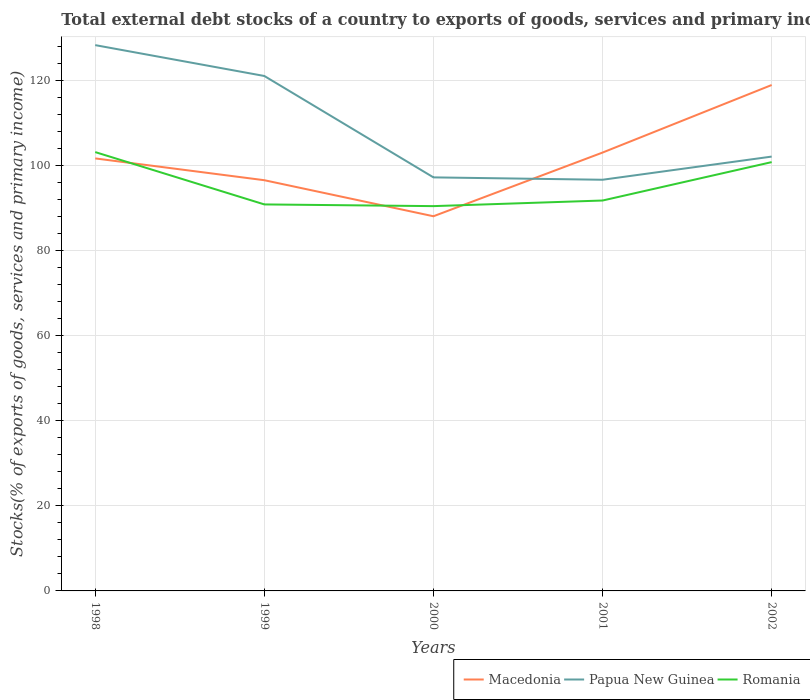How many different coloured lines are there?
Your answer should be very brief. 3. Does the line corresponding to Papua New Guinea intersect with the line corresponding to Macedonia?
Provide a short and direct response. Yes. Is the number of lines equal to the number of legend labels?
Give a very brief answer. Yes. Across all years, what is the maximum total debt stocks in Papua New Guinea?
Ensure brevity in your answer.  96.73. What is the total total debt stocks in Papua New Guinea in the graph?
Keep it short and to the point. 31.11. What is the difference between the highest and the second highest total debt stocks in Romania?
Offer a very short reply. 12.71. What is the difference between the highest and the lowest total debt stocks in Macedonia?
Give a very brief answer. 3. Is the total debt stocks in Papua New Guinea strictly greater than the total debt stocks in Romania over the years?
Make the answer very short. No. How many lines are there?
Offer a terse response. 3. How many years are there in the graph?
Offer a terse response. 5. What is the difference between two consecutive major ticks on the Y-axis?
Offer a very short reply. 20. Are the values on the major ticks of Y-axis written in scientific E-notation?
Offer a terse response. No. How many legend labels are there?
Provide a short and direct response. 3. How are the legend labels stacked?
Give a very brief answer. Horizontal. What is the title of the graph?
Keep it short and to the point. Total external debt stocks of a country to exports of goods, services and primary income. What is the label or title of the Y-axis?
Ensure brevity in your answer.  Stocks(% of exports of goods, services and primary income). What is the Stocks(% of exports of goods, services and primary income) in Macedonia in 1998?
Give a very brief answer. 101.75. What is the Stocks(% of exports of goods, services and primary income) in Papua New Guinea in 1998?
Make the answer very short. 128.4. What is the Stocks(% of exports of goods, services and primary income) of Romania in 1998?
Your response must be concise. 103.24. What is the Stocks(% of exports of goods, services and primary income) in Macedonia in 1999?
Your answer should be very brief. 96.62. What is the Stocks(% of exports of goods, services and primary income) in Papua New Guinea in 1999?
Offer a terse response. 121.14. What is the Stocks(% of exports of goods, services and primary income) of Romania in 1999?
Your answer should be very brief. 90.93. What is the Stocks(% of exports of goods, services and primary income) in Macedonia in 2000?
Keep it short and to the point. 88.14. What is the Stocks(% of exports of goods, services and primary income) in Papua New Guinea in 2000?
Your response must be concise. 97.29. What is the Stocks(% of exports of goods, services and primary income) of Romania in 2000?
Give a very brief answer. 90.52. What is the Stocks(% of exports of goods, services and primary income) of Macedonia in 2001?
Provide a short and direct response. 103.13. What is the Stocks(% of exports of goods, services and primary income) of Papua New Guinea in 2001?
Ensure brevity in your answer.  96.73. What is the Stocks(% of exports of goods, services and primary income) in Romania in 2001?
Give a very brief answer. 91.84. What is the Stocks(% of exports of goods, services and primary income) in Macedonia in 2002?
Provide a short and direct response. 119.02. What is the Stocks(% of exports of goods, services and primary income) in Papua New Guinea in 2002?
Offer a terse response. 102.18. What is the Stocks(% of exports of goods, services and primary income) in Romania in 2002?
Your answer should be very brief. 100.88. Across all years, what is the maximum Stocks(% of exports of goods, services and primary income) of Macedonia?
Give a very brief answer. 119.02. Across all years, what is the maximum Stocks(% of exports of goods, services and primary income) in Papua New Guinea?
Provide a succinct answer. 128.4. Across all years, what is the maximum Stocks(% of exports of goods, services and primary income) of Romania?
Provide a short and direct response. 103.24. Across all years, what is the minimum Stocks(% of exports of goods, services and primary income) of Macedonia?
Provide a succinct answer. 88.14. Across all years, what is the minimum Stocks(% of exports of goods, services and primary income) in Papua New Guinea?
Your response must be concise. 96.73. Across all years, what is the minimum Stocks(% of exports of goods, services and primary income) in Romania?
Provide a short and direct response. 90.52. What is the total Stocks(% of exports of goods, services and primary income) in Macedonia in the graph?
Offer a very short reply. 508.66. What is the total Stocks(% of exports of goods, services and primary income) of Papua New Guinea in the graph?
Give a very brief answer. 545.74. What is the total Stocks(% of exports of goods, services and primary income) in Romania in the graph?
Your answer should be compact. 477.41. What is the difference between the Stocks(% of exports of goods, services and primary income) of Macedonia in 1998 and that in 1999?
Ensure brevity in your answer.  5.13. What is the difference between the Stocks(% of exports of goods, services and primary income) in Papua New Guinea in 1998 and that in 1999?
Give a very brief answer. 7.26. What is the difference between the Stocks(% of exports of goods, services and primary income) in Romania in 1998 and that in 1999?
Give a very brief answer. 12.31. What is the difference between the Stocks(% of exports of goods, services and primary income) of Macedonia in 1998 and that in 2000?
Your answer should be very brief. 13.61. What is the difference between the Stocks(% of exports of goods, services and primary income) of Papua New Guinea in 1998 and that in 2000?
Your response must be concise. 31.11. What is the difference between the Stocks(% of exports of goods, services and primary income) in Romania in 1998 and that in 2000?
Make the answer very short. 12.71. What is the difference between the Stocks(% of exports of goods, services and primary income) of Macedonia in 1998 and that in 2001?
Keep it short and to the point. -1.38. What is the difference between the Stocks(% of exports of goods, services and primary income) in Papua New Guinea in 1998 and that in 2001?
Your response must be concise. 31.67. What is the difference between the Stocks(% of exports of goods, services and primary income) of Romania in 1998 and that in 2001?
Ensure brevity in your answer.  11.39. What is the difference between the Stocks(% of exports of goods, services and primary income) of Macedonia in 1998 and that in 2002?
Offer a terse response. -17.27. What is the difference between the Stocks(% of exports of goods, services and primary income) in Papua New Guinea in 1998 and that in 2002?
Make the answer very short. 26.22. What is the difference between the Stocks(% of exports of goods, services and primary income) of Romania in 1998 and that in 2002?
Give a very brief answer. 2.36. What is the difference between the Stocks(% of exports of goods, services and primary income) of Macedonia in 1999 and that in 2000?
Make the answer very short. 8.48. What is the difference between the Stocks(% of exports of goods, services and primary income) in Papua New Guinea in 1999 and that in 2000?
Offer a terse response. 23.85. What is the difference between the Stocks(% of exports of goods, services and primary income) in Romania in 1999 and that in 2000?
Make the answer very short. 0.4. What is the difference between the Stocks(% of exports of goods, services and primary income) in Macedonia in 1999 and that in 2001?
Keep it short and to the point. -6.5. What is the difference between the Stocks(% of exports of goods, services and primary income) of Papua New Guinea in 1999 and that in 2001?
Provide a short and direct response. 24.41. What is the difference between the Stocks(% of exports of goods, services and primary income) of Romania in 1999 and that in 2001?
Make the answer very short. -0.92. What is the difference between the Stocks(% of exports of goods, services and primary income) in Macedonia in 1999 and that in 2002?
Provide a succinct answer. -22.39. What is the difference between the Stocks(% of exports of goods, services and primary income) of Papua New Guinea in 1999 and that in 2002?
Make the answer very short. 18.96. What is the difference between the Stocks(% of exports of goods, services and primary income) in Romania in 1999 and that in 2002?
Give a very brief answer. -9.95. What is the difference between the Stocks(% of exports of goods, services and primary income) in Macedonia in 2000 and that in 2001?
Make the answer very short. -14.98. What is the difference between the Stocks(% of exports of goods, services and primary income) in Papua New Guinea in 2000 and that in 2001?
Give a very brief answer. 0.56. What is the difference between the Stocks(% of exports of goods, services and primary income) in Romania in 2000 and that in 2001?
Ensure brevity in your answer.  -1.32. What is the difference between the Stocks(% of exports of goods, services and primary income) in Macedonia in 2000 and that in 2002?
Make the answer very short. -30.88. What is the difference between the Stocks(% of exports of goods, services and primary income) of Papua New Guinea in 2000 and that in 2002?
Keep it short and to the point. -4.89. What is the difference between the Stocks(% of exports of goods, services and primary income) in Romania in 2000 and that in 2002?
Provide a short and direct response. -10.35. What is the difference between the Stocks(% of exports of goods, services and primary income) in Macedonia in 2001 and that in 2002?
Make the answer very short. -15.89. What is the difference between the Stocks(% of exports of goods, services and primary income) in Papua New Guinea in 2001 and that in 2002?
Keep it short and to the point. -5.45. What is the difference between the Stocks(% of exports of goods, services and primary income) in Romania in 2001 and that in 2002?
Provide a short and direct response. -9.03. What is the difference between the Stocks(% of exports of goods, services and primary income) of Macedonia in 1998 and the Stocks(% of exports of goods, services and primary income) of Papua New Guinea in 1999?
Make the answer very short. -19.39. What is the difference between the Stocks(% of exports of goods, services and primary income) in Macedonia in 1998 and the Stocks(% of exports of goods, services and primary income) in Romania in 1999?
Keep it short and to the point. 10.82. What is the difference between the Stocks(% of exports of goods, services and primary income) of Papua New Guinea in 1998 and the Stocks(% of exports of goods, services and primary income) of Romania in 1999?
Offer a very short reply. 37.47. What is the difference between the Stocks(% of exports of goods, services and primary income) of Macedonia in 1998 and the Stocks(% of exports of goods, services and primary income) of Papua New Guinea in 2000?
Give a very brief answer. 4.46. What is the difference between the Stocks(% of exports of goods, services and primary income) of Macedonia in 1998 and the Stocks(% of exports of goods, services and primary income) of Romania in 2000?
Keep it short and to the point. 11.23. What is the difference between the Stocks(% of exports of goods, services and primary income) of Papua New Guinea in 1998 and the Stocks(% of exports of goods, services and primary income) of Romania in 2000?
Offer a terse response. 37.88. What is the difference between the Stocks(% of exports of goods, services and primary income) in Macedonia in 1998 and the Stocks(% of exports of goods, services and primary income) in Papua New Guinea in 2001?
Offer a terse response. 5.02. What is the difference between the Stocks(% of exports of goods, services and primary income) in Macedonia in 1998 and the Stocks(% of exports of goods, services and primary income) in Romania in 2001?
Provide a short and direct response. 9.91. What is the difference between the Stocks(% of exports of goods, services and primary income) of Papua New Guinea in 1998 and the Stocks(% of exports of goods, services and primary income) of Romania in 2001?
Give a very brief answer. 36.56. What is the difference between the Stocks(% of exports of goods, services and primary income) in Macedonia in 1998 and the Stocks(% of exports of goods, services and primary income) in Papua New Guinea in 2002?
Your response must be concise. -0.43. What is the difference between the Stocks(% of exports of goods, services and primary income) of Macedonia in 1998 and the Stocks(% of exports of goods, services and primary income) of Romania in 2002?
Your answer should be very brief. 0.87. What is the difference between the Stocks(% of exports of goods, services and primary income) of Papua New Guinea in 1998 and the Stocks(% of exports of goods, services and primary income) of Romania in 2002?
Offer a very short reply. 27.52. What is the difference between the Stocks(% of exports of goods, services and primary income) in Macedonia in 1999 and the Stocks(% of exports of goods, services and primary income) in Papua New Guinea in 2000?
Your answer should be compact. -0.67. What is the difference between the Stocks(% of exports of goods, services and primary income) of Macedonia in 1999 and the Stocks(% of exports of goods, services and primary income) of Romania in 2000?
Make the answer very short. 6.1. What is the difference between the Stocks(% of exports of goods, services and primary income) in Papua New Guinea in 1999 and the Stocks(% of exports of goods, services and primary income) in Romania in 2000?
Your answer should be compact. 30.62. What is the difference between the Stocks(% of exports of goods, services and primary income) of Macedonia in 1999 and the Stocks(% of exports of goods, services and primary income) of Papua New Guinea in 2001?
Your answer should be compact. -0.11. What is the difference between the Stocks(% of exports of goods, services and primary income) of Macedonia in 1999 and the Stocks(% of exports of goods, services and primary income) of Romania in 2001?
Provide a short and direct response. 4.78. What is the difference between the Stocks(% of exports of goods, services and primary income) of Papua New Guinea in 1999 and the Stocks(% of exports of goods, services and primary income) of Romania in 2001?
Your answer should be compact. 29.3. What is the difference between the Stocks(% of exports of goods, services and primary income) of Macedonia in 1999 and the Stocks(% of exports of goods, services and primary income) of Papua New Guinea in 2002?
Provide a short and direct response. -5.56. What is the difference between the Stocks(% of exports of goods, services and primary income) of Macedonia in 1999 and the Stocks(% of exports of goods, services and primary income) of Romania in 2002?
Provide a short and direct response. -4.25. What is the difference between the Stocks(% of exports of goods, services and primary income) in Papua New Guinea in 1999 and the Stocks(% of exports of goods, services and primary income) in Romania in 2002?
Provide a succinct answer. 20.26. What is the difference between the Stocks(% of exports of goods, services and primary income) in Macedonia in 2000 and the Stocks(% of exports of goods, services and primary income) in Papua New Guinea in 2001?
Your answer should be compact. -8.59. What is the difference between the Stocks(% of exports of goods, services and primary income) of Macedonia in 2000 and the Stocks(% of exports of goods, services and primary income) of Romania in 2001?
Keep it short and to the point. -3.7. What is the difference between the Stocks(% of exports of goods, services and primary income) of Papua New Guinea in 2000 and the Stocks(% of exports of goods, services and primary income) of Romania in 2001?
Your answer should be very brief. 5.44. What is the difference between the Stocks(% of exports of goods, services and primary income) in Macedonia in 2000 and the Stocks(% of exports of goods, services and primary income) in Papua New Guinea in 2002?
Provide a succinct answer. -14.04. What is the difference between the Stocks(% of exports of goods, services and primary income) in Macedonia in 2000 and the Stocks(% of exports of goods, services and primary income) in Romania in 2002?
Provide a short and direct response. -12.74. What is the difference between the Stocks(% of exports of goods, services and primary income) in Papua New Guinea in 2000 and the Stocks(% of exports of goods, services and primary income) in Romania in 2002?
Your response must be concise. -3.59. What is the difference between the Stocks(% of exports of goods, services and primary income) in Macedonia in 2001 and the Stocks(% of exports of goods, services and primary income) in Papua New Guinea in 2002?
Offer a very short reply. 0.95. What is the difference between the Stocks(% of exports of goods, services and primary income) in Macedonia in 2001 and the Stocks(% of exports of goods, services and primary income) in Romania in 2002?
Provide a succinct answer. 2.25. What is the difference between the Stocks(% of exports of goods, services and primary income) of Papua New Guinea in 2001 and the Stocks(% of exports of goods, services and primary income) of Romania in 2002?
Ensure brevity in your answer.  -4.15. What is the average Stocks(% of exports of goods, services and primary income) of Macedonia per year?
Provide a succinct answer. 101.73. What is the average Stocks(% of exports of goods, services and primary income) of Papua New Guinea per year?
Make the answer very short. 109.15. What is the average Stocks(% of exports of goods, services and primary income) in Romania per year?
Provide a succinct answer. 95.48. In the year 1998, what is the difference between the Stocks(% of exports of goods, services and primary income) in Macedonia and Stocks(% of exports of goods, services and primary income) in Papua New Guinea?
Provide a succinct answer. -26.65. In the year 1998, what is the difference between the Stocks(% of exports of goods, services and primary income) of Macedonia and Stocks(% of exports of goods, services and primary income) of Romania?
Provide a short and direct response. -1.49. In the year 1998, what is the difference between the Stocks(% of exports of goods, services and primary income) of Papua New Guinea and Stocks(% of exports of goods, services and primary income) of Romania?
Your answer should be very brief. 25.16. In the year 1999, what is the difference between the Stocks(% of exports of goods, services and primary income) of Macedonia and Stocks(% of exports of goods, services and primary income) of Papua New Guinea?
Offer a terse response. -24.52. In the year 1999, what is the difference between the Stocks(% of exports of goods, services and primary income) in Macedonia and Stocks(% of exports of goods, services and primary income) in Romania?
Ensure brevity in your answer.  5.7. In the year 1999, what is the difference between the Stocks(% of exports of goods, services and primary income) of Papua New Guinea and Stocks(% of exports of goods, services and primary income) of Romania?
Your answer should be compact. 30.21. In the year 2000, what is the difference between the Stocks(% of exports of goods, services and primary income) in Macedonia and Stocks(% of exports of goods, services and primary income) in Papua New Guinea?
Ensure brevity in your answer.  -9.15. In the year 2000, what is the difference between the Stocks(% of exports of goods, services and primary income) in Macedonia and Stocks(% of exports of goods, services and primary income) in Romania?
Ensure brevity in your answer.  -2.38. In the year 2000, what is the difference between the Stocks(% of exports of goods, services and primary income) in Papua New Guinea and Stocks(% of exports of goods, services and primary income) in Romania?
Your response must be concise. 6.76. In the year 2001, what is the difference between the Stocks(% of exports of goods, services and primary income) in Macedonia and Stocks(% of exports of goods, services and primary income) in Papua New Guinea?
Keep it short and to the point. 6.4. In the year 2001, what is the difference between the Stocks(% of exports of goods, services and primary income) in Macedonia and Stocks(% of exports of goods, services and primary income) in Romania?
Provide a succinct answer. 11.28. In the year 2001, what is the difference between the Stocks(% of exports of goods, services and primary income) in Papua New Guinea and Stocks(% of exports of goods, services and primary income) in Romania?
Offer a very short reply. 4.89. In the year 2002, what is the difference between the Stocks(% of exports of goods, services and primary income) of Macedonia and Stocks(% of exports of goods, services and primary income) of Papua New Guinea?
Make the answer very short. 16.84. In the year 2002, what is the difference between the Stocks(% of exports of goods, services and primary income) of Macedonia and Stocks(% of exports of goods, services and primary income) of Romania?
Your answer should be very brief. 18.14. In the year 2002, what is the difference between the Stocks(% of exports of goods, services and primary income) of Papua New Guinea and Stocks(% of exports of goods, services and primary income) of Romania?
Offer a very short reply. 1.3. What is the ratio of the Stocks(% of exports of goods, services and primary income) of Macedonia in 1998 to that in 1999?
Your response must be concise. 1.05. What is the ratio of the Stocks(% of exports of goods, services and primary income) of Papua New Guinea in 1998 to that in 1999?
Make the answer very short. 1.06. What is the ratio of the Stocks(% of exports of goods, services and primary income) in Romania in 1998 to that in 1999?
Keep it short and to the point. 1.14. What is the ratio of the Stocks(% of exports of goods, services and primary income) in Macedonia in 1998 to that in 2000?
Provide a succinct answer. 1.15. What is the ratio of the Stocks(% of exports of goods, services and primary income) in Papua New Guinea in 1998 to that in 2000?
Provide a succinct answer. 1.32. What is the ratio of the Stocks(% of exports of goods, services and primary income) of Romania in 1998 to that in 2000?
Your response must be concise. 1.14. What is the ratio of the Stocks(% of exports of goods, services and primary income) in Macedonia in 1998 to that in 2001?
Provide a succinct answer. 0.99. What is the ratio of the Stocks(% of exports of goods, services and primary income) in Papua New Guinea in 1998 to that in 2001?
Your answer should be compact. 1.33. What is the ratio of the Stocks(% of exports of goods, services and primary income) of Romania in 1998 to that in 2001?
Offer a terse response. 1.12. What is the ratio of the Stocks(% of exports of goods, services and primary income) in Macedonia in 1998 to that in 2002?
Provide a short and direct response. 0.85. What is the ratio of the Stocks(% of exports of goods, services and primary income) in Papua New Guinea in 1998 to that in 2002?
Give a very brief answer. 1.26. What is the ratio of the Stocks(% of exports of goods, services and primary income) of Romania in 1998 to that in 2002?
Your response must be concise. 1.02. What is the ratio of the Stocks(% of exports of goods, services and primary income) in Macedonia in 1999 to that in 2000?
Make the answer very short. 1.1. What is the ratio of the Stocks(% of exports of goods, services and primary income) of Papua New Guinea in 1999 to that in 2000?
Ensure brevity in your answer.  1.25. What is the ratio of the Stocks(% of exports of goods, services and primary income) of Macedonia in 1999 to that in 2001?
Provide a short and direct response. 0.94. What is the ratio of the Stocks(% of exports of goods, services and primary income) in Papua New Guinea in 1999 to that in 2001?
Offer a very short reply. 1.25. What is the ratio of the Stocks(% of exports of goods, services and primary income) in Macedonia in 1999 to that in 2002?
Offer a very short reply. 0.81. What is the ratio of the Stocks(% of exports of goods, services and primary income) in Papua New Guinea in 1999 to that in 2002?
Offer a terse response. 1.19. What is the ratio of the Stocks(% of exports of goods, services and primary income) of Romania in 1999 to that in 2002?
Offer a very short reply. 0.9. What is the ratio of the Stocks(% of exports of goods, services and primary income) in Macedonia in 2000 to that in 2001?
Give a very brief answer. 0.85. What is the ratio of the Stocks(% of exports of goods, services and primary income) of Papua New Guinea in 2000 to that in 2001?
Provide a succinct answer. 1.01. What is the ratio of the Stocks(% of exports of goods, services and primary income) in Romania in 2000 to that in 2001?
Ensure brevity in your answer.  0.99. What is the ratio of the Stocks(% of exports of goods, services and primary income) in Macedonia in 2000 to that in 2002?
Keep it short and to the point. 0.74. What is the ratio of the Stocks(% of exports of goods, services and primary income) of Papua New Guinea in 2000 to that in 2002?
Provide a succinct answer. 0.95. What is the ratio of the Stocks(% of exports of goods, services and primary income) of Romania in 2000 to that in 2002?
Your answer should be compact. 0.9. What is the ratio of the Stocks(% of exports of goods, services and primary income) in Macedonia in 2001 to that in 2002?
Provide a short and direct response. 0.87. What is the ratio of the Stocks(% of exports of goods, services and primary income) of Papua New Guinea in 2001 to that in 2002?
Keep it short and to the point. 0.95. What is the ratio of the Stocks(% of exports of goods, services and primary income) of Romania in 2001 to that in 2002?
Your answer should be compact. 0.91. What is the difference between the highest and the second highest Stocks(% of exports of goods, services and primary income) of Macedonia?
Make the answer very short. 15.89. What is the difference between the highest and the second highest Stocks(% of exports of goods, services and primary income) of Papua New Guinea?
Provide a short and direct response. 7.26. What is the difference between the highest and the second highest Stocks(% of exports of goods, services and primary income) in Romania?
Ensure brevity in your answer.  2.36. What is the difference between the highest and the lowest Stocks(% of exports of goods, services and primary income) in Macedonia?
Your response must be concise. 30.88. What is the difference between the highest and the lowest Stocks(% of exports of goods, services and primary income) of Papua New Guinea?
Ensure brevity in your answer.  31.67. What is the difference between the highest and the lowest Stocks(% of exports of goods, services and primary income) in Romania?
Provide a short and direct response. 12.71. 